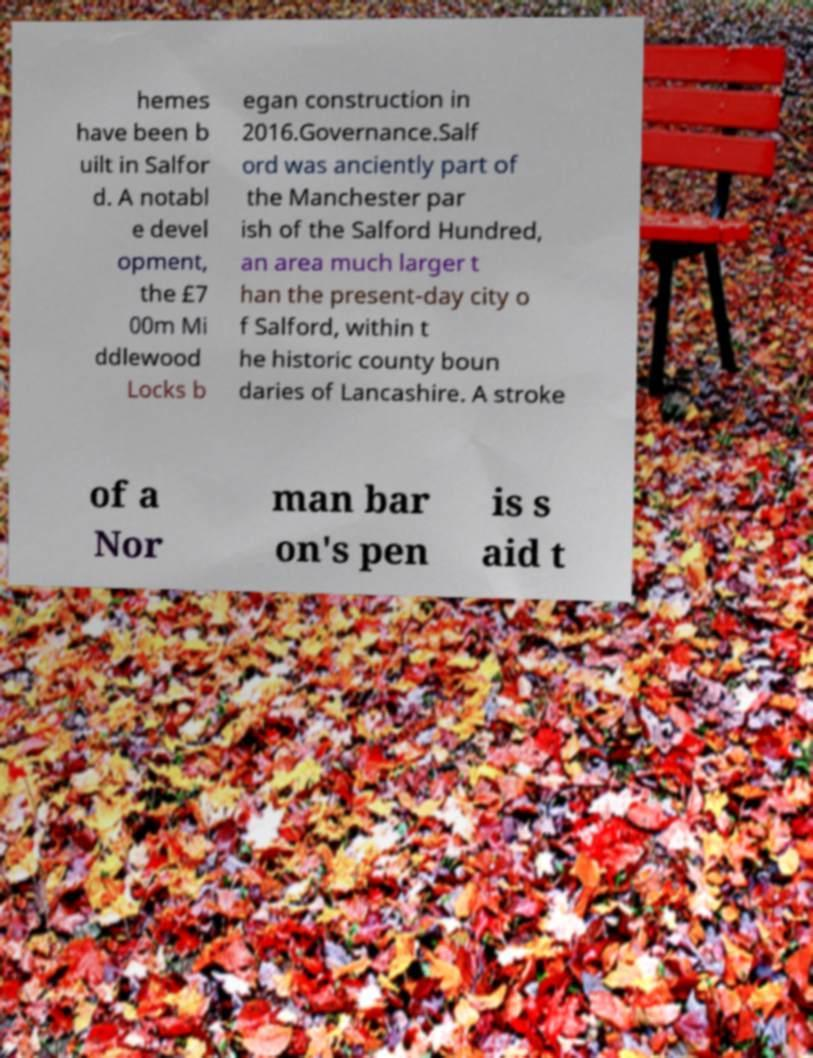Could you assist in decoding the text presented in this image and type it out clearly? hemes have been b uilt in Salfor d. A notabl e devel opment, the £7 00m Mi ddlewood Locks b egan construction in 2016.Governance.Salf ord was anciently part of the Manchester par ish of the Salford Hundred, an area much larger t han the present-day city o f Salford, within t he historic county boun daries of Lancashire. A stroke of a Nor man bar on's pen is s aid t 